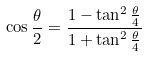Convert formula to latex. <formula><loc_0><loc_0><loc_500><loc_500>\cos { \frac { \theta } { 2 } } = \frac { 1 - \tan ^ { 2 } \frac { \theta } { 4 } } { 1 + \tan ^ { 2 } \frac { \theta } { 4 } }</formula> 